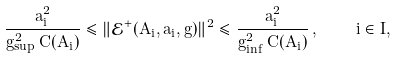Convert formula to latex. <formula><loc_0><loc_0><loc_500><loc_500>\frac { a ^ { 2 } _ { i } } { g _ { \sup } ^ { 2 } \, C ( A _ { i } ) } \leqslant \| \mathcal { E } ^ { + } ( A _ { i } , a _ { i } , g ) \| ^ { 2 } \leqslant \frac { a ^ { 2 } _ { i } } { g _ { \inf } ^ { 2 } \, C ( A _ { i } ) } \, , \quad i \in I ,</formula> 